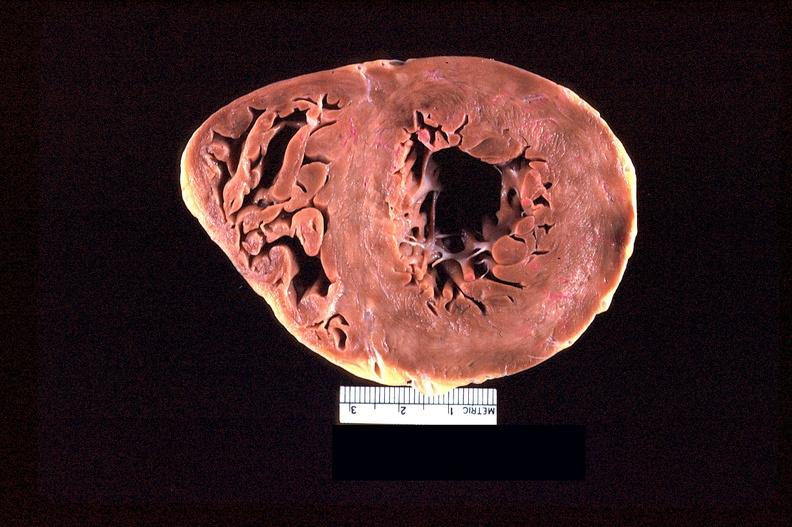what does this image show?
Answer the question using a single word or phrase. Heart slice 